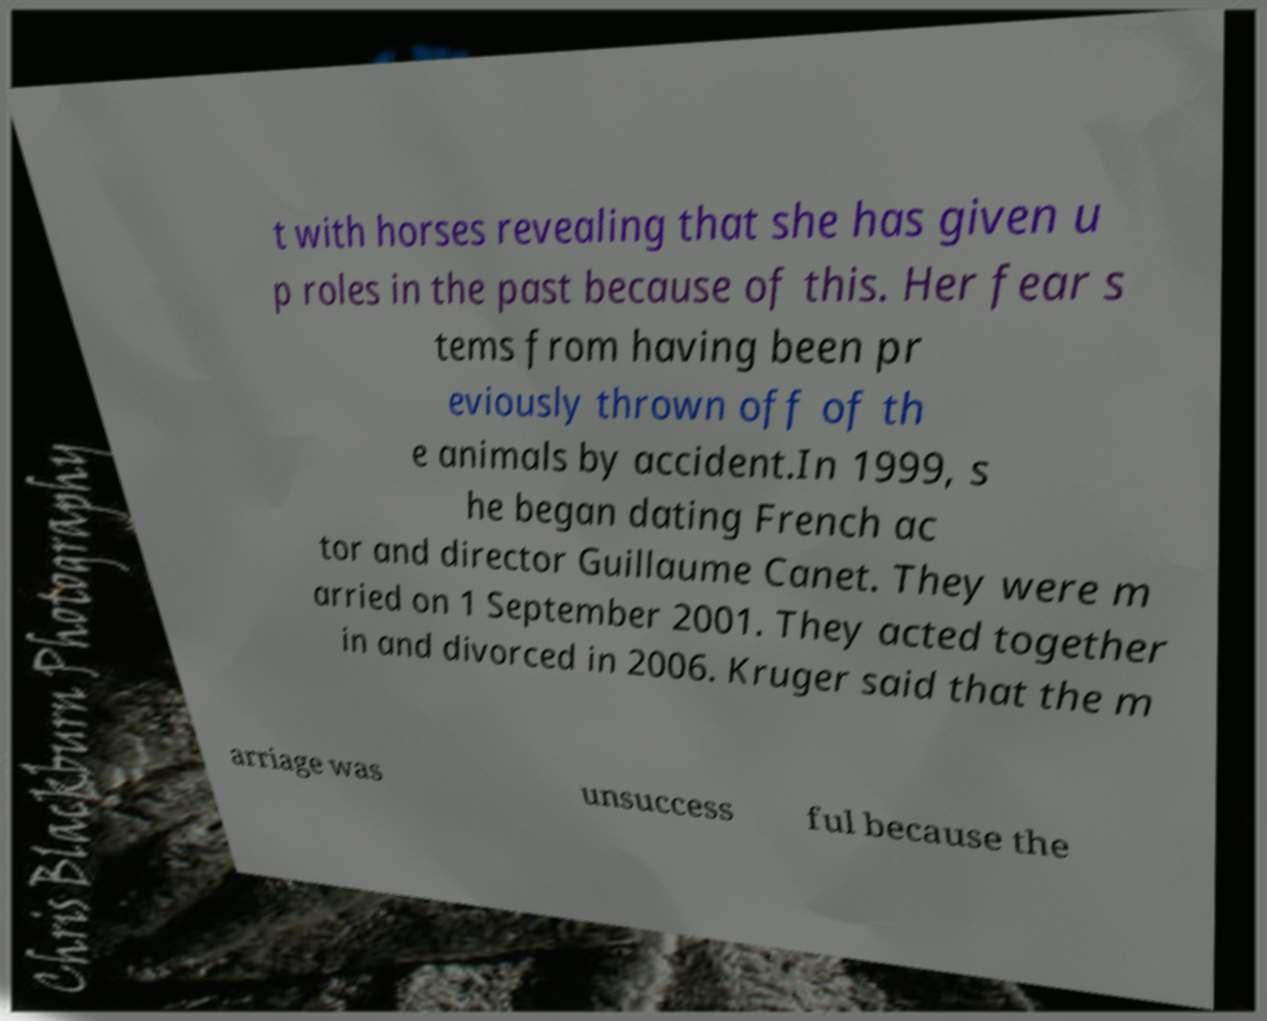Can you accurately transcribe the text from the provided image for me? t with horses revealing that she has given u p roles in the past because of this. Her fear s tems from having been pr eviously thrown off of th e animals by accident.In 1999, s he began dating French ac tor and director Guillaume Canet. They were m arried on 1 September 2001. They acted together in and divorced in 2006. Kruger said that the m arriage was unsuccess ful because the 